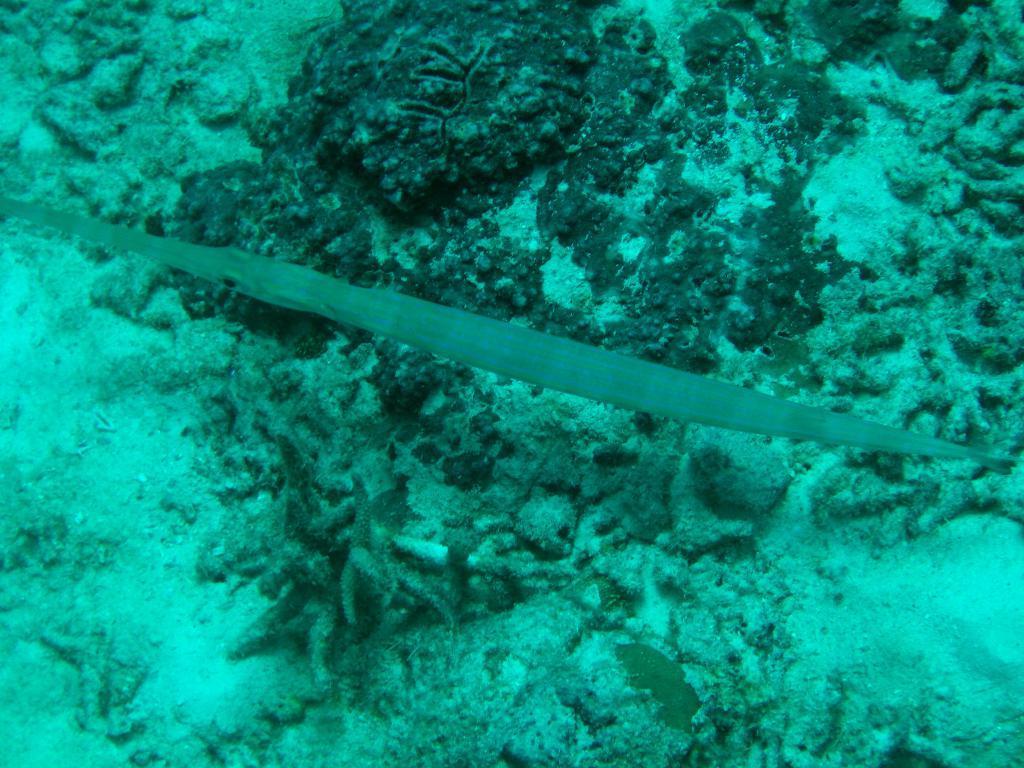Could you give a brief overview of what you see in this image? In this picture we can see underwater environment. 